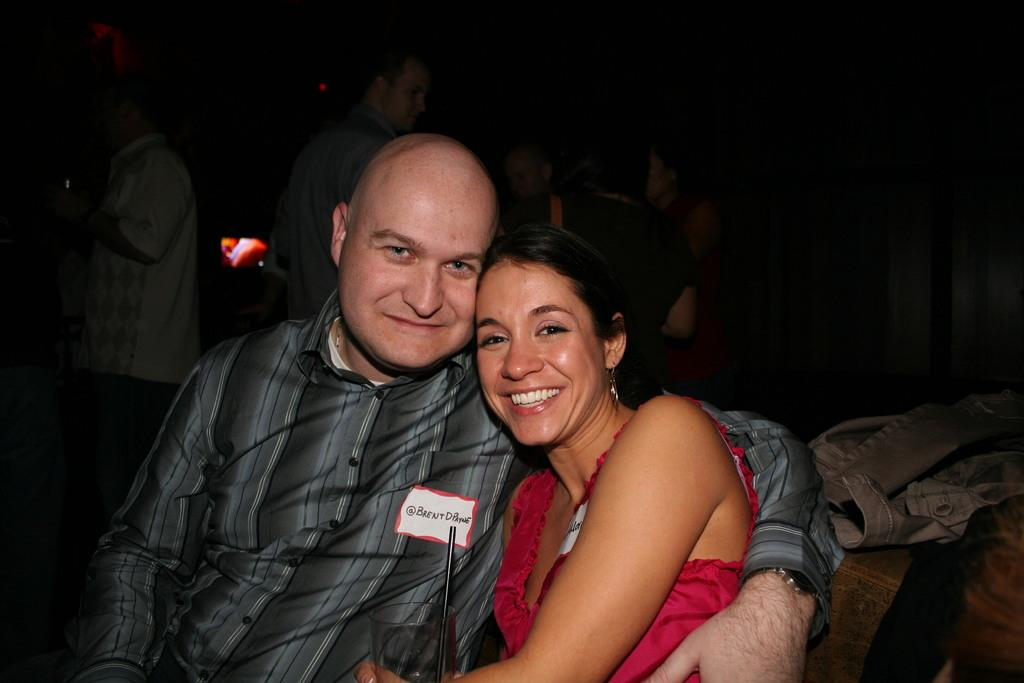What are the two people in the image doing? There is a man and a woman seated in the image. What is the woman holding in her hand? The woman is holding a glass with a straw in her hand. What can be seen in the background of the image? There are people standing in the background of the image, and there appears to be a television. Can you see any coils, clams, or cobwebs in the image? No, there are no coils, clams, or cobwebs present in the image. 